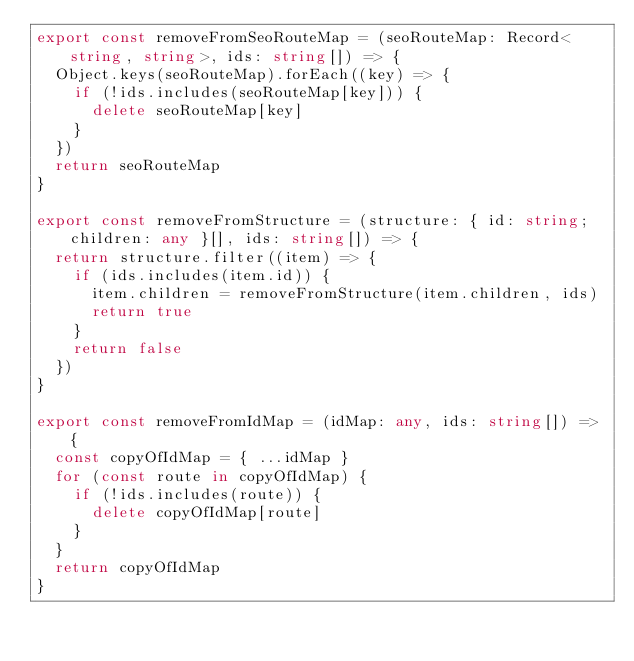<code> <loc_0><loc_0><loc_500><loc_500><_TypeScript_>export const removeFromSeoRouteMap = (seoRouteMap: Record<string, string>, ids: string[]) => {
  Object.keys(seoRouteMap).forEach((key) => {
    if (!ids.includes(seoRouteMap[key])) {
      delete seoRouteMap[key]
    }
  })
  return seoRouteMap
}

export const removeFromStructure = (structure: { id: string; children: any }[], ids: string[]) => {
  return structure.filter((item) => {
    if (ids.includes(item.id)) {
      item.children = removeFromStructure(item.children, ids)
      return true
    }
    return false
  })
}

export const removeFromIdMap = (idMap: any, ids: string[]) => {
  const copyOfIdMap = { ...idMap }
  for (const route in copyOfIdMap) {
    if (!ids.includes(route)) {
      delete copyOfIdMap[route]
    }
  }
  return copyOfIdMap
}
</code> 